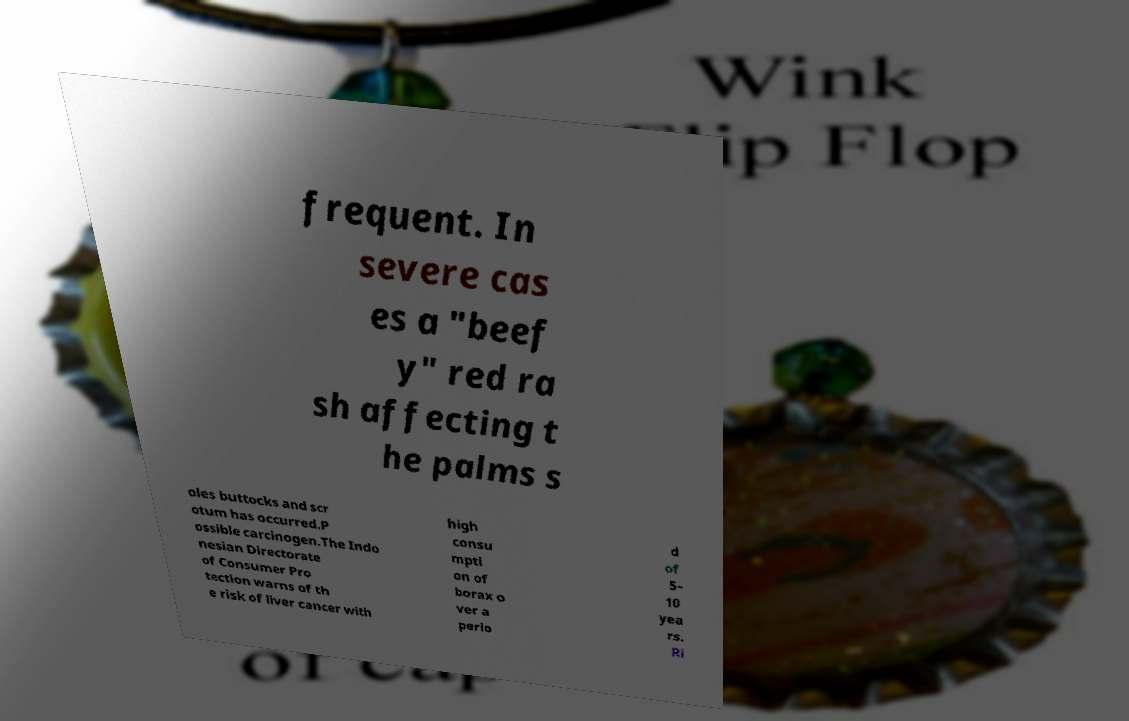Can you accurately transcribe the text from the provided image for me? frequent. In severe cas es a "beef y" red ra sh affecting t he palms s oles buttocks and scr otum has occurred.P ossible carcinogen.The Indo nesian Directorate of Consumer Pro tection warns of th e risk of liver cancer with high consu mpti on of borax o ver a perio d of 5– 10 yea rs. Ri 